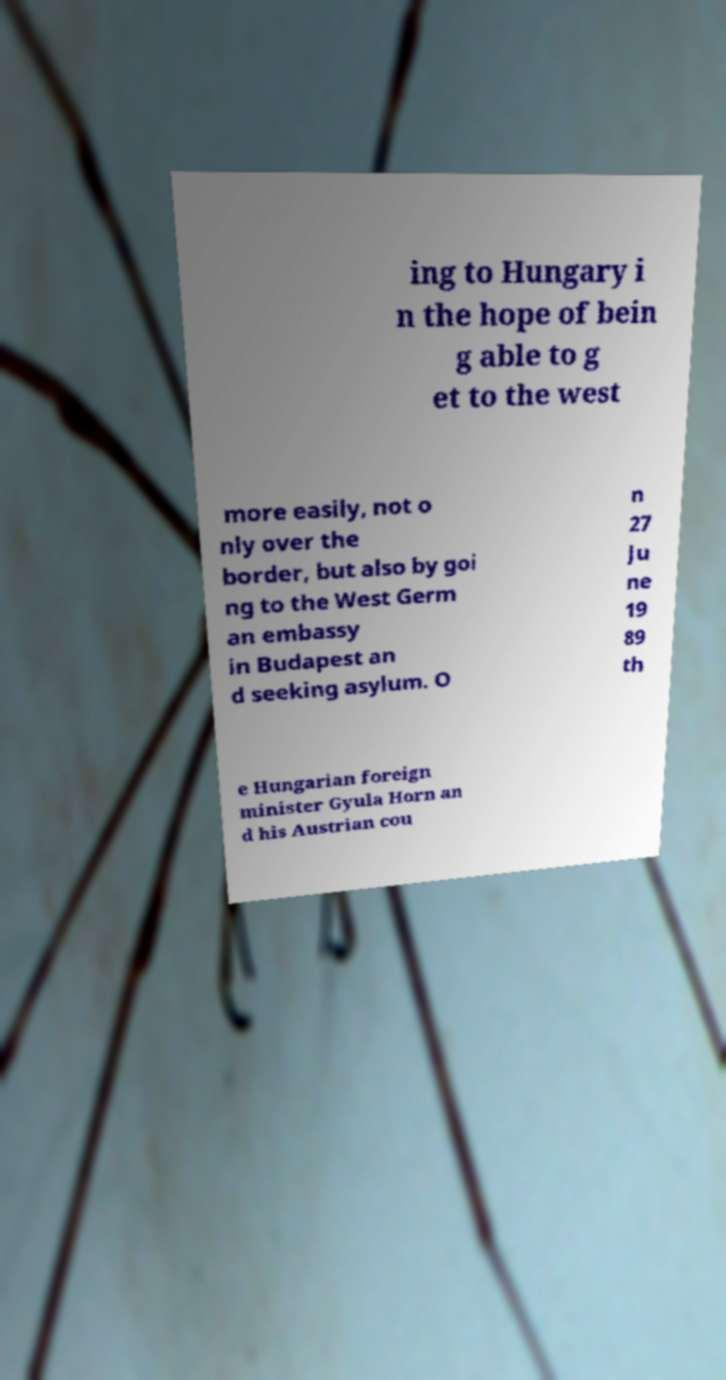I need the written content from this picture converted into text. Can you do that? ing to Hungary i n the hope of bein g able to g et to the west more easily, not o nly over the border, but also by goi ng to the West Germ an embassy in Budapest an d seeking asylum. O n 27 Ju ne 19 89 th e Hungarian foreign minister Gyula Horn an d his Austrian cou 